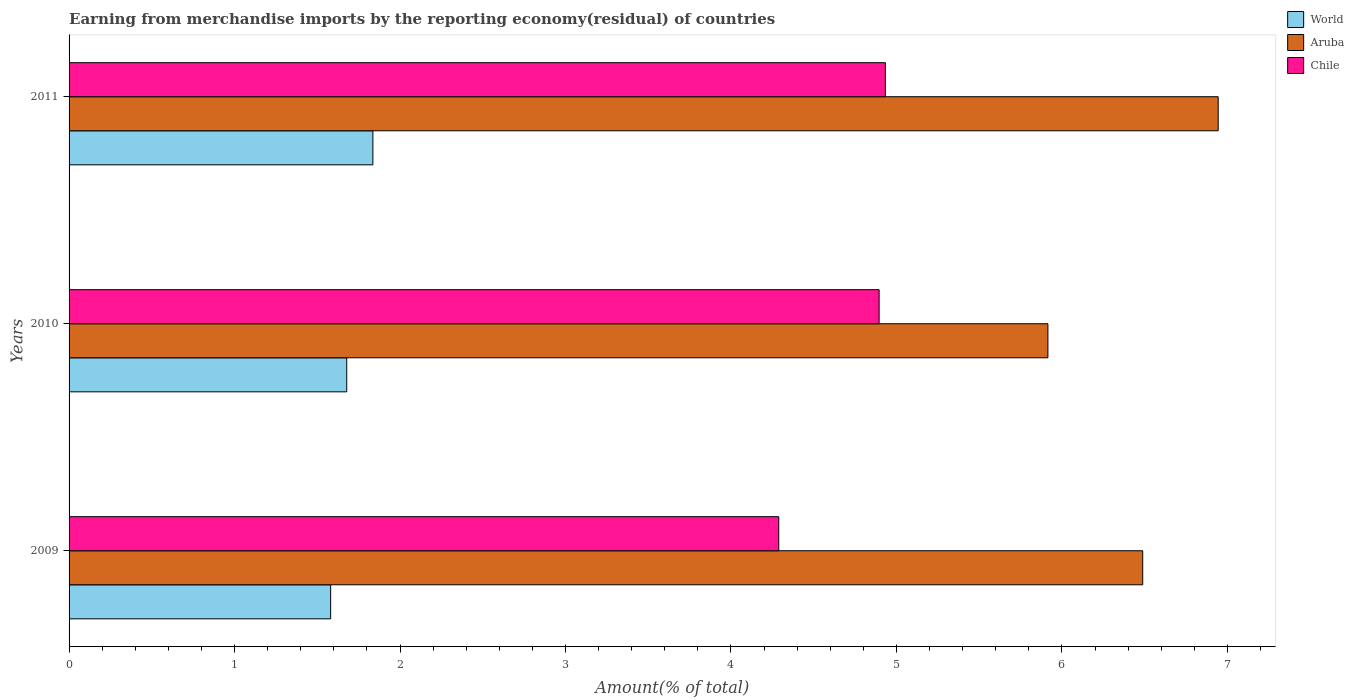How many different coloured bars are there?
Offer a terse response. 3. How many groups of bars are there?
Your answer should be very brief. 3. How many bars are there on the 2nd tick from the top?
Keep it short and to the point. 3. What is the percentage of amount earned from merchandise imports in Aruba in 2009?
Keep it short and to the point. 6.49. Across all years, what is the maximum percentage of amount earned from merchandise imports in Aruba?
Provide a short and direct response. 6.94. Across all years, what is the minimum percentage of amount earned from merchandise imports in Aruba?
Your answer should be very brief. 5.92. In which year was the percentage of amount earned from merchandise imports in Aruba maximum?
Your answer should be compact. 2011. What is the total percentage of amount earned from merchandise imports in World in the graph?
Provide a succinct answer. 5.09. What is the difference between the percentage of amount earned from merchandise imports in Chile in 2010 and that in 2011?
Your response must be concise. -0.04. What is the difference between the percentage of amount earned from merchandise imports in World in 2009 and the percentage of amount earned from merchandise imports in Aruba in 2011?
Your answer should be compact. -5.36. What is the average percentage of amount earned from merchandise imports in Aruba per year?
Offer a terse response. 6.45. In the year 2011, what is the difference between the percentage of amount earned from merchandise imports in World and percentage of amount earned from merchandise imports in Aruba?
Ensure brevity in your answer.  -5.11. In how many years, is the percentage of amount earned from merchandise imports in World greater than 4.8 %?
Your response must be concise. 0. What is the ratio of the percentage of amount earned from merchandise imports in Aruba in 2010 to that in 2011?
Make the answer very short. 0.85. Is the percentage of amount earned from merchandise imports in Chile in 2009 less than that in 2011?
Offer a terse response. Yes. What is the difference between the highest and the second highest percentage of amount earned from merchandise imports in Chile?
Ensure brevity in your answer.  0.04. What is the difference between the highest and the lowest percentage of amount earned from merchandise imports in World?
Your response must be concise. 0.26. In how many years, is the percentage of amount earned from merchandise imports in World greater than the average percentage of amount earned from merchandise imports in World taken over all years?
Your response must be concise. 1. Is the sum of the percentage of amount earned from merchandise imports in Chile in 2010 and 2011 greater than the maximum percentage of amount earned from merchandise imports in World across all years?
Provide a succinct answer. Yes. What does the 2nd bar from the top in 2010 represents?
Make the answer very short. Aruba. What does the 3rd bar from the bottom in 2011 represents?
Provide a short and direct response. Chile. How many bars are there?
Provide a succinct answer. 9. Are all the bars in the graph horizontal?
Ensure brevity in your answer.  Yes. Does the graph contain any zero values?
Give a very brief answer. No. Where does the legend appear in the graph?
Ensure brevity in your answer.  Top right. What is the title of the graph?
Ensure brevity in your answer.  Earning from merchandise imports by the reporting economy(residual) of countries. Does "Guatemala" appear as one of the legend labels in the graph?
Offer a terse response. No. What is the label or title of the X-axis?
Offer a very short reply. Amount(% of total). What is the Amount(% of total) of World in 2009?
Make the answer very short. 1.58. What is the Amount(% of total) of Aruba in 2009?
Make the answer very short. 6.49. What is the Amount(% of total) of Chile in 2009?
Make the answer very short. 4.29. What is the Amount(% of total) in World in 2010?
Make the answer very short. 1.68. What is the Amount(% of total) in Aruba in 2010?
Keep it short and to the point. 5.92. What is the Amount(% of total) of Chile in 2010?
Offer a very short reply. 4.9. What is the Amount(% of total) of World in 2011?
Your answer should be very brief. 1.84. What is the Amount(% of total) of Aruba in 2011?
Keep it short and to the point. 6.94. What is the Amount(% of total) of Chile in 2011?
Your response must be concise. 4.93. Across all years, what is the maximum Amount(% of total) of World?
Provide a short and direct response. 1.84. Across all years, what is the maximum Amount(% of total) in Aruba?
Your response must be concise. 6.94. Across all years, what is the maximum Amount(% of total) of Chile?
Make the answer very short. 4.93. Across all years, what is the minimum Amount(% of total) in World?
Provide a succinct answer. 1.58. Across all years, what is the minimum Amount(% of total) in Aruba?
Provide a succinct answer. 5.92. Across all years, what is the minimum Amount(% of total) of Chile?
Give a very brief answer. 4.29. What is the total Amount(% of total) of World in the graph?
Your answer should be very brief. 5.09. What is the total Amount(% of total) in Aruba in the graph?
Provide a short and direct response. 19.35. What is the total Amount(% of total) of Chile in the graph?
Offer a terse response. 14.12. What is the difference between the Amount(% of total) in World in 2009 and that in 2010?
Make the answer very short. -0.1. What is the difference between the Amount(% of total) of Aruba in 2009 and that in 2010?
Keep it short and to the point. 0.57. What is the difference between the Amount(% of total) in Chile in 2009 and that in 2010?
Keep it short and to the point. -0.61. What is the difference between the Amount(% of total) of World in 2009 and that in 2011?
Ensure brevity in your answer.  -0.26. What is the difference between the Amount(% of total) of Aruba in 2009 and that in 2011?
Offer a very short reply. -0.46. What is the difference between the Amount(% of total) in Chile in 2009 and that in 2011?
Your answer should be very brief. -0.64. What is the difference between the Amount(% of total) in World in 2010 and that in 2011?
Your answer should be very brief. -0.16. What is the difference between the Amount(% of total) in Aruba in 2010 and that in 2011?
Provide a succinct answer. -1.03. What is the difference between the Amount(% of total) in Chile in 2010 and that in 2011?
Give a very brief answer. -0.04. What is the difference between the Amount(% of total) of World in 2009 and the Amount(% of total) of Aruba in 2010?
Make the answer very short. -4.33. What is the difference between the Amount(% of total) in World in 2009 and the Amount(% of total) in Chile in 2010?
Give a very brief answer. -3.31. What is the difference between the Amount(% of total) in Aruba in 2009 and the Amount(% of total) in Chile in 2010?
Your answer should be very brief. 1.59. What is the difference between the Amount(% of total) of World in 2009 and the Amount(% of total) of Aruba in 2011?
Offer a very short reply. -5.36. What is the difference between the Amount(% of total) of World in 2009 and the Amount(% of total) of Chile in 2011?
Give a very brief answer. -3.35. What is the difference between the Amount(% of total) in Aruba in 2009 and the Amount(% of total) in Chile in 2011?
Provide a short and direct response. 1.56. What is the difference between the Amount(% of total) of World in 2010 and the Amount(% of total) of Aruba in 2011?
Provide a short and direct response. -5.27. What is the difference between the Amount(% of total) in World in 2010 and the Amount(% of total) in Chile in 2011?
Ensure brevity in your answer.  -3.26. What is the difference between the Amount(% of total) in Aruba in 2010 and the Amount(% of total) in Chile in 2011?
Provide a succinct answer. 0.98. What is the average Amount(% of total) of World per year?
Offer a terse response. 1.7. What is the average Amount(% of total) of Aruba per year?
Provide a succinct answer. 6.45. What is the average Amount(% of total) in Chile per year?
Offer a terse response. 4.71. In the year 2009, what is the difference between the Amount(% of total) of World and Amount(% of total) of Aruba?
Provide a succinct answer. -4.91. In the year 2009, what is the difference between the Amount(% of total) in World and Amount(% of total) in Chile?
Your response must be concise. -2.71. In the year 2009, what is the difference between the Amount(% of total) in Aruba and Amount(% of total) in Chile?
Your answer should be compact. 2.2. In the year 2010, what is the difference between the Amount(% of total) of World and Amount(% of total) of Aruba?
Offer a terse response. -4.24. In the year 2010, what is the difference between the Amount(% of total) of World and Amount(% of total) of Chile?
Offer a terse response. -3.22. In the year 2010, what is the difference between the Amount(% of total) of Aruba and Amount(% of total) of Chile?
Make the answer very short. 1.02. In the year 2011, what is the difference between the Amount(% of total) in World and Amount(% of total) in Aruba?
Provide a short and direct response. -5.11. In the year 2011, what is the difference between the Amount(% of total) of World and Amount(% of total) of Chile?
Provide a short and direct response. -3.1. In the year 2011, what is the difference between the Amount(% of total) of Aruba and Amount(% of total) of Chile?
Provide a short and direct response. 2.01. What is the ratio of the Amount(% of total) in World in 2009 to that in 2010?
Your answer should be very brief. 0.94. What is the ratio of the Amount(% of total) in Aruba in 2009 to that in 2010?
Your answer should be compact. 1.1. What is the ratio of the Amount(% of total) in Chile in 2009 to that in 2010?
Provide a succinct answer. 0.88. What is the ratio of the Amount(% of total) of World in 2009 to that in 2011?
Give a very brief answer. 0.86. What is the ratio of the Amount(% of total) of Aruba in 2009 to that in 2011?
Keep it short and to the point. 0.93. What is the ratio of the Amount(% of total) of Chile in 2009 to that in 2011?
Offer a very short reply. 0.87. What is the ratio of the Amount(% of total) of World in 2010 to that in 2011?
Offer a terse response. 0.91. What is the ratio of the Amount(% of total) in Aruba in 2010 to that in 2011?
Offer a very short reply. 0.85. What is the difference between the highest and the second highest Amount(% of total) of World?
Offer a very short reply. 0.16. What is the difference between the highest and the second highest Amount(% of total) of Aruba?
Offer a terse response. 0.46. What is the difference between the highest and the second highest Amount(% of total) of Chile?
Provide a short and direct response. 0.04. What is the difference between the highest and the lowest Amount(% of total) in World?
Offer a very short reply. 0.26. What is the difference between the highest and the lowest Amount(% of total) in Aruba?
Provide a succinct answer. 1.03. What is the difference between the highest and the lowest Amount(% of total) of Chile?
Keep it short and to the point. 0.64. 